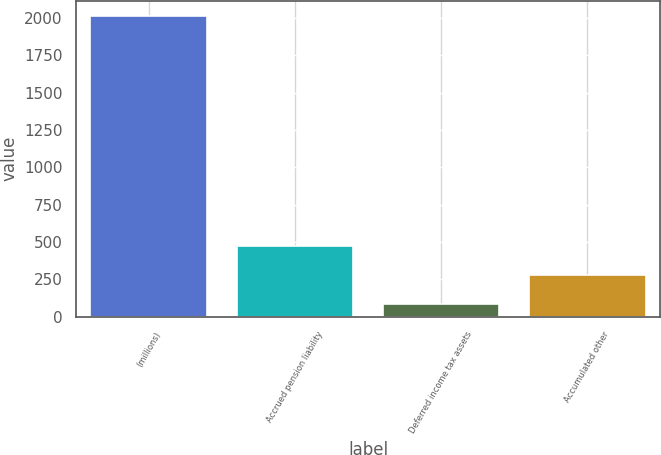Convert chart to OTSL. <chart><loc_0><loc_0><loc_500><loc_500><bar_chart><fcel>(millions)<fcel>Accrued pension liability<fcel>Deferred income tax assets<fcel>Accumulated other<nl><fcel>2014<fcel>473.12<fcel>87.9<fcel>280.51<nl></chart> 